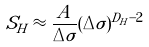<formula> <loc_0><loc_0><loc_500><loc_500>S _ { H } \approx \frac { A } { \Delta \sigma } ( \Delta \sigma ) ^ { D _ { H } - 2 }</formula> 